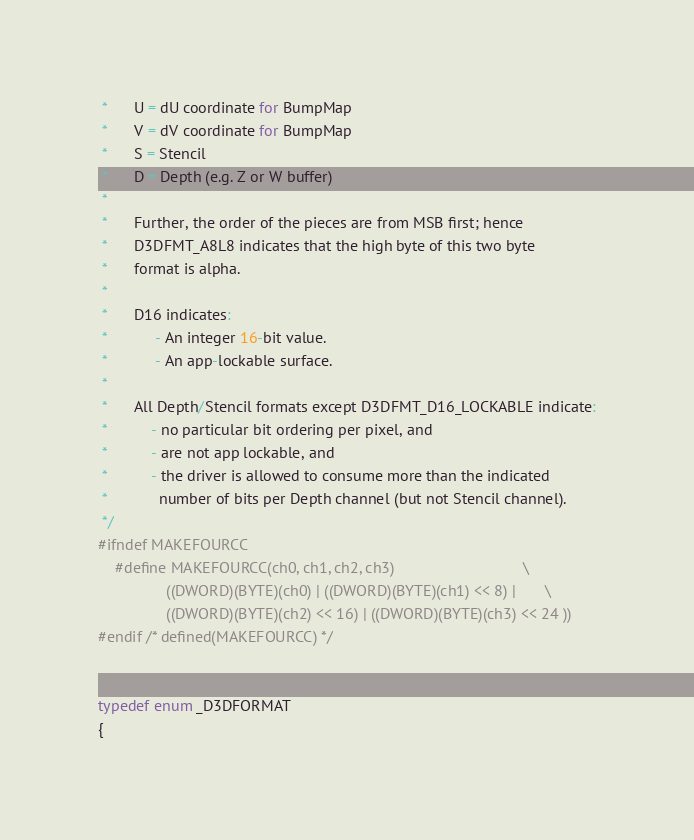Convert code to text. <code><loc_0><loc_0><loc_500><loc_500><_C_> *      U = dU coordinate for BumpMap
 *      V = dV coordinate for BumpMap
 *      S = Stencil
 *      D = Depth (e.g. Z or W buffer)
 *
 *      Further, the order of the pieces are from MSB first; hence
 *      D3DFMT_A8L8 indicates that the high byte of this two byte
 *      format is alpha.
 *
 *      D16 indicates:
 *           - An integer 16-bit value.
 *           - An app-lockable surface.
 *
 *      All Depth/Stencil formats except D3DFMT_D16_LOCKABLE indicate:
 *          - no particular bit ordering per pixel, and
 *          - are not app lockable, and
 *          - the driver is allowed to consume more than the indicated
 *            number of bits per Depth channel (but not Stencil channel).
 */
#ifndef MAKEFOURCC
    #define MAKEFOURCC(ch0, ch1, ch2, ch3)                              \
                ((DWORD)(BYTE)(ch0) | ((DWORD)(BYTE)(ch1) << 8) |       \
                ((DWORD)(BYTE)(ch2) << 16) | ((DWORD)(BYTE)(ch3) << 24 ))
#endif /* defined(MAKEFOURCC) */


typedef enum _D3DFORMAT
{</code> 